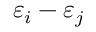Convert formula to latex. <formula><loc_0><loc_0><loc_500><loc_500>\varepsilon _ { i } - \varepsilon _ { j }</formula> 